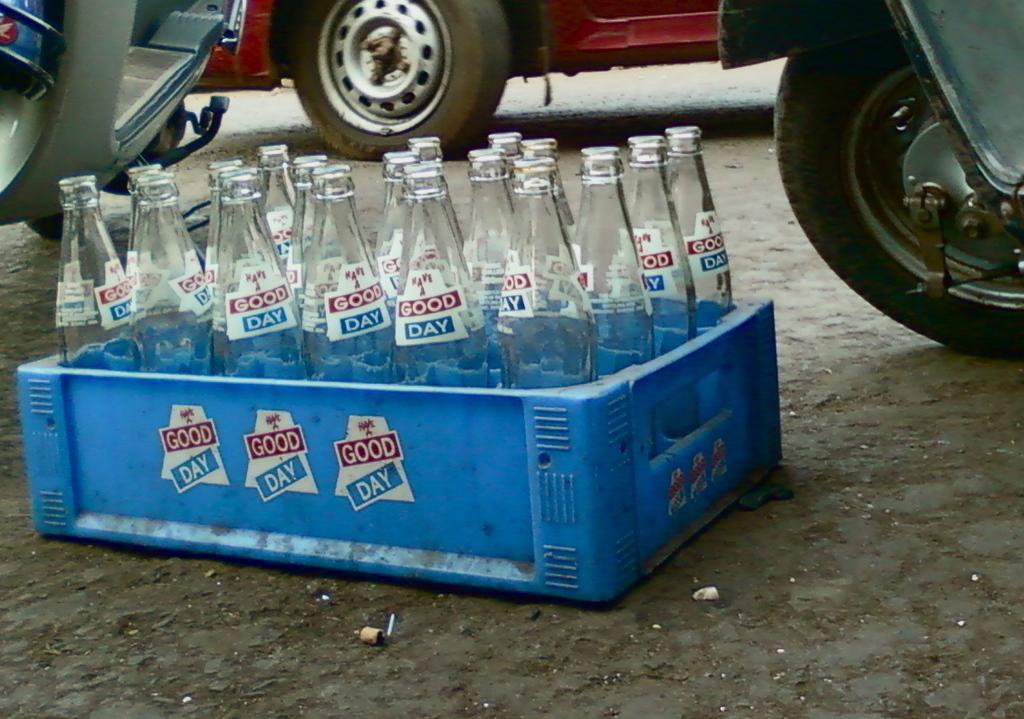Can you describe this image briefly? In this image i can see a tray with a number of bottles in it. In the background i can see a wheel of the vehicle and few vehicles. 